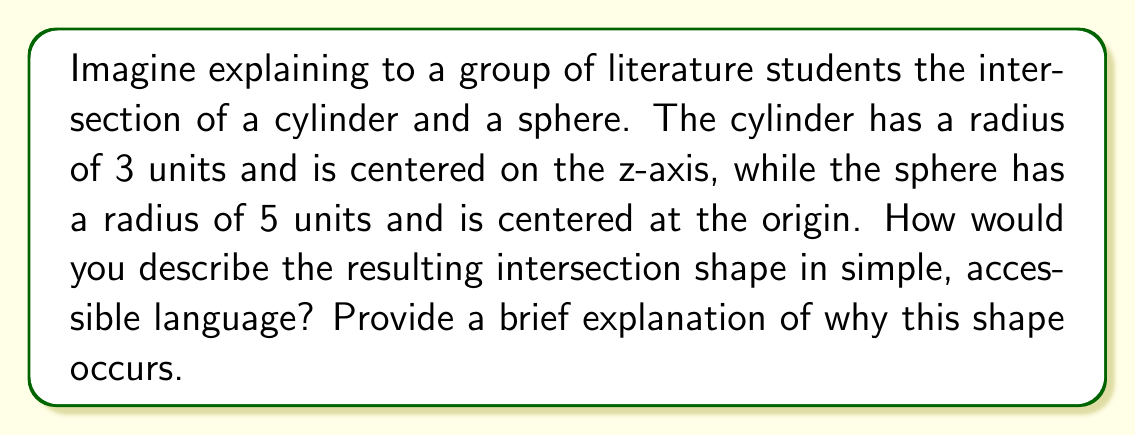Teach me how to tackle this problem. To explain this intersection to literature students, we can break it down into simple steps:

1. Visualize the shapes:
   - Picture a cylinder standing upright along the z-axis, like a tall can.
   - Now imagine a sphere centered at the origin, like a large ball.

2. Understand the intersection:
   - Where these shapes overlap is our intersection.
   - Since the sphere is larger (radius 5) than the cylinder's width (radius 3), it will completely engulf the cylinder's circular base.

3. Describe the resulting shape:
   - The intersection forms a shape called a "curved cylinder" or a "barrel-like" shape.
   - It's like taking a cylinder and pushing in its sides to create a gentle curve.

4. Explain why this shape occurs:
   - The top and bottom of the intersection are circular, matching the cylinder's cross-section.
   - The sides are curved because they follow the sphere's surface.

Mathematically, we can describe this intersection as:

$$x^2 + y^2 = 9$$ (cylinder equation)
$$x^2 + y^2 + z^2 = 25$$ (sphere equation)

The intersection occurs where both equations are satisfied. Solving for z:

$$z^2 = 25 - (x^2 + y^2) = 25 - 9 = 16$$
$$z = \pm 4$$

This means the intersection extends 4 units above and below the xy-plane, with a circular cross-section of radius 3 at any point along its height.

[asy]
import three;

size(200);
currentprojection=perspective(6,3,2);

// Draw sphere
draw(surface(sphere((0,0,0),5)),lightblue+opacity(0.3));

// Draw cylinder
draw(surface(cylinder((0,0,-4),4,3)),lightgreen+opacity(0.3));

// Draw intersection
draw(surface(cylinder((0,0,-4),8,3)),red+opacity(0.7));

// Labels
label("Sphere",(-5,-2,0),W);
label("Cylinder",(4,0,5),E);
label("Intersection",(0,-3.5,0),S);
[/asy]
Answer: The intersection of the cylinder and sphere forms a curved cylindrical shape, often described as "barrel-like." It has circular top and bottom faces (radius 3 units) and curved sides that bulge outward, following the sphere's curvature. The shape extends 4 units above and below the xy-plane. 